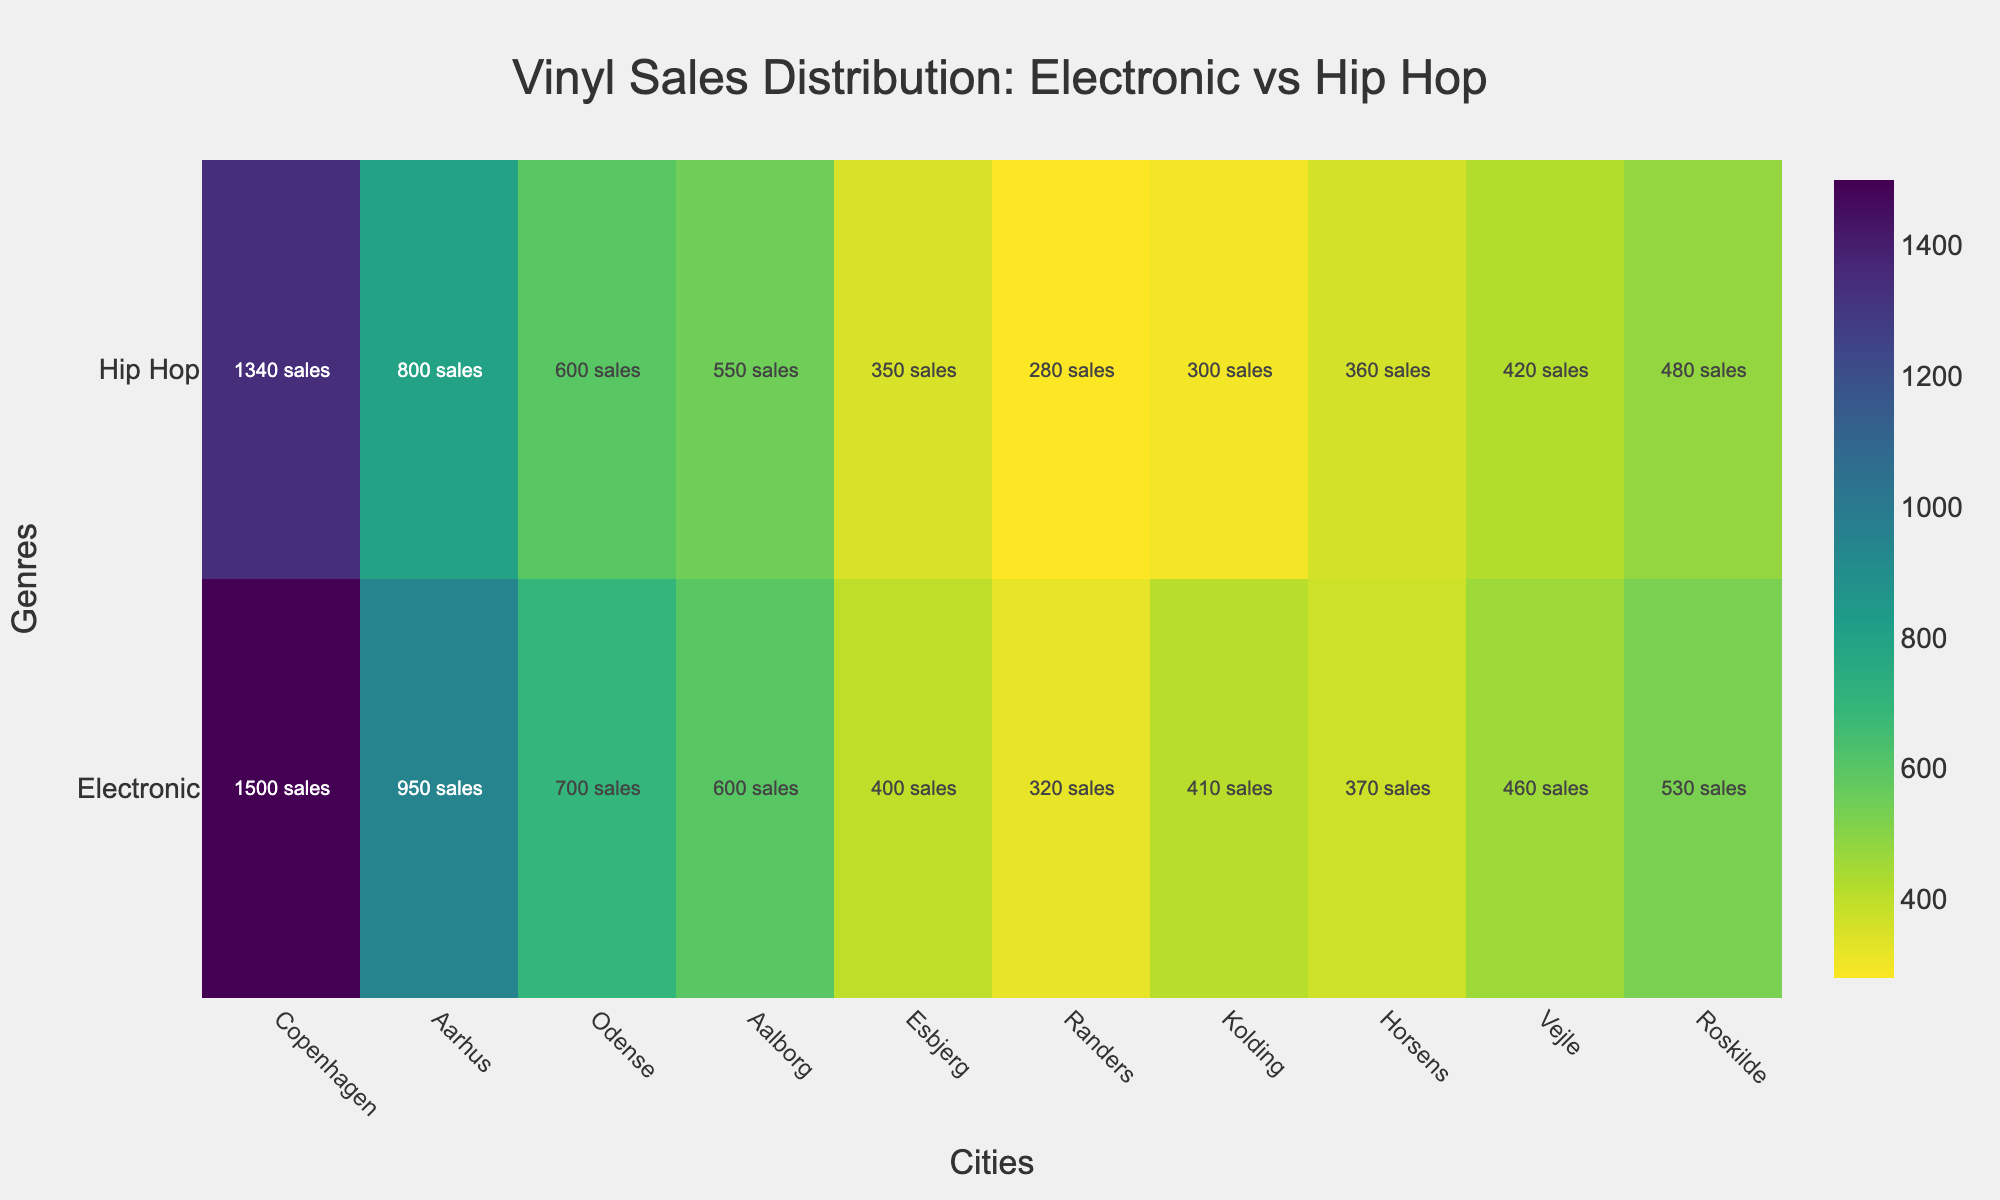what is the title of the heatmap? The title of the heatmap is displayed prominently at the top of the figure. It is usually larger and more distinct than other text.
Answer: Vinyl Sales Distribution: Electronic vs Hip Hop How many cities are represented on the heatmap? By counting the number of distinct city names along the x-axis, we can determine the number of cities. There are distinct markers for each city.
Answer: 10 Which genre has higher vinyl sales in Copenhagen? Look at the values for Copenhagen in both the 'Electronic' and 'Hip Hop' rows. Compare the numbers to see which one is higher. The 'Electronic' row shows 1500 while the 'Hip Hop' row shows 1340.
Answer: Electronic What is the difference in sales between Electronic and Hip Hop genres in Aarhus? Locate Aarhus on the x-axis, then check the values in both the 'Electronic' and 'Hip Hop' rows. Subtract the Hip Hop sales value from the Electronic sales value (950 - 800).
Answer: 150 Which city has the lowest Hip Hop vinyl sales? Compare the Hip Hop sales values for all cities. The city with the smallest number in the 'Hip Hop' row is the one with the lowest sales.
Answer: Randers What is the total sales of electronic vinyls in Odense and Aalborg combined? Find the sales values of Electronic vinyls for both Odense and Aalborg, then add these values together (700 + 600).
Answer: 1300 In which city is the difference between Electronic and Hip Hop vinyl sales the smallest? Compute the differences between Electronic and Hip Hop sales for each city and find the smallest difference. Check cities individually, considering the absolute difference in sales for each pair.
Answer: Horsens Which genre shows more consistent sales across all cities? Check the variation in the sales values for both genres across all cities. Consistency means smaller differences among the values. 'Hip Hop' sales show smaller variations compared to 'Electronic'.
Answer: Hip Hop What's the combined total of vinyl sales for both genres in Esbjerg? Sum the sales values of both Electronic and Hip Hop genres in Esbjerg (400 + 350).
Answer: 750 Which city has the highest Electronic vinyl sales? Look at the values in the 'Electronic' row and identify the highest number. The city corresponding to this number on the x-axis is your answer.
Answer: Copenhagen 